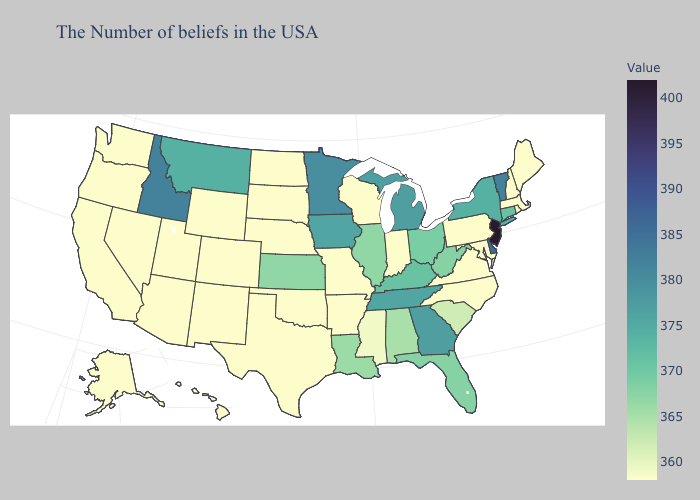Does New Jersey have the highest value in the USA?
Quick response, please. Yes. Does New Hampshire have the highest value in the Northeast?
Quick response, please. No. Does New Hampshire have the lowest value in the Northeast?
Quick response, please. Yes. Does Pennsylvania have the highest value in the USA?
Be succinct. No. Does Kansas have the lowest value in the MidWest?
Quick response, please. No. Which states have the lowest value in the USA?
Short answer required. Maine, Massachusetts, Rhode Island, New Hampshire, Maryland, Pennsylvania, Virginia, North Carolina, Indiana, Wisconsin, Missouri, Arkansas, Nebraska, Oklahoma, Texas, South Dakota, North Dakota, Wyoming, Colorado, New Mexico, Utah, Arizona, Nevada, California, Washington, Oregon, Alaska, Hawaii. Which states have the highest value in the USA?
Short answer required. New Jersey. 